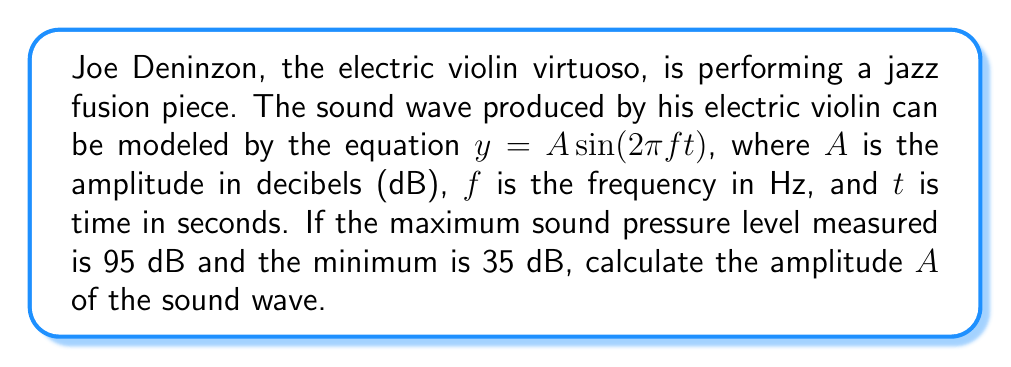What is the answer to this math problem? To solve this problem, we need to understand that the amplitude of a sound wave is half the difference between its maximum and minimum values. Let's break it down step-by-step:

1) The maximum sound pressure level is 95 dB, and the minimum is 35 dB.

2) The total range of the sound wave is:
   $$95 \text{ dB} - 35 \text{ dB} = 60 \text{ dB}$$

3) The amplitude is half of this range:
   $$A = \frac{1}{2} \times 60 \text{ dB} = 30 \text{ dB}$$

4) We can verify this by considering the sinusoidal nature of the sound wave:
   - At the wave's peak, $\sin(2\pi ft) = 1$, so $y = A = 30 \text{ dB}$
   - At the wave's trough, $\sin(2\pi ft) = -1$, so $y = -A = -30 \text{ dB}$

5) The center of the wave oscillation is at:
   $$\frac{95 \text{ dB} + 35 \text{ dB}}{2} = 65 \text{ dB}$$

6) From this center, the wave oscillates 30 dB up (to 95 dB) and 30 dB down (to 35 dB), confirming our calculation.

Therefore, the amplitude of Joe Deninzon's electric violin sound wave is 30 dB.
Answer: $A = 30 \text{ dB}$ 